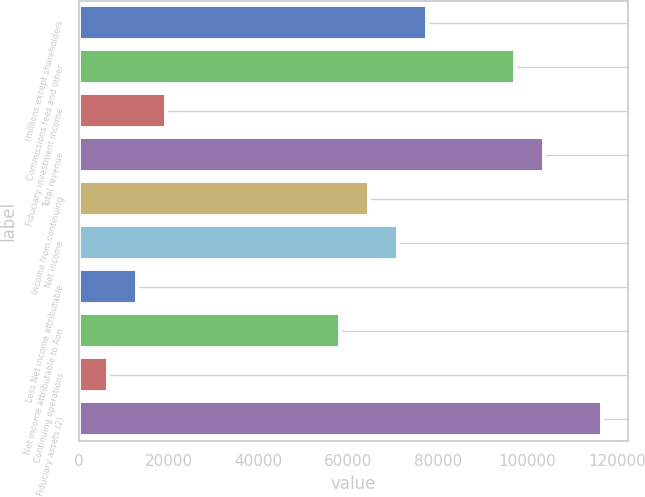<chart> <loc_0><loc_0><loc_500><loc_500><bar_chart><fcel>(millions except shareholders<fcel>Commissions fees and other<fcel>Fiduciary investment income<fcel>Total revenue<fcel>Income from continuing<fcel>Net income<fcel>Less Net income attributable<fcel>Net income attributable to Aon<fcel>Continuing operations<fcel>Fiduciary assets (2)<nl><fcel>77669.9<fcel>97087.2<fcel>19417.9<fcel>103560<fcel>64725<fcel>71197.5<fcel>12945.5<fcel>58252.6<fcel>6473.06<fcel>116505<nl></chart> 